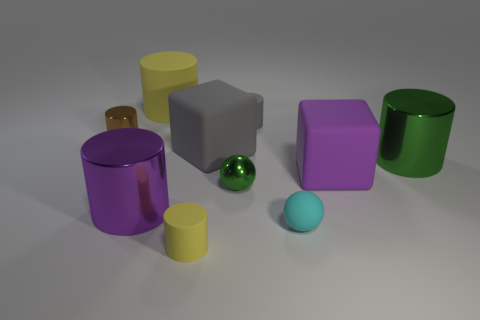Can you tell me the different colors of the cylinders in the image? Certainly! In the image, we can see cylinders in several colors: there's a yellow cylinder, a purple cylinder with a reflective surface, and another smaller matte purple cylinder. Additionally, there's a green cylinder with a reflective surface. 